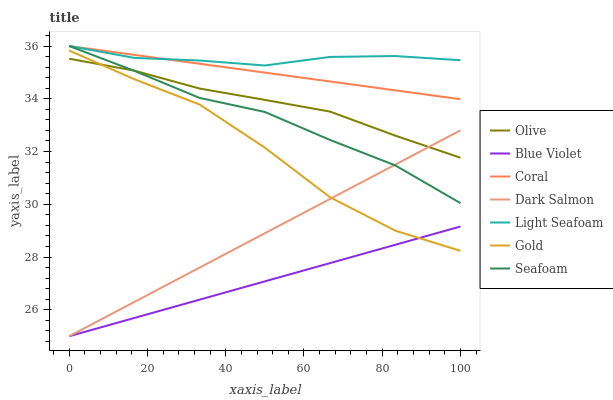Does Blue Violet have the minimum area under the curve?
Answer yes or no. Yes. Does Light Seafoam have the maximum area under the curve?
Answer yes or no. Yes. Does Coral have the minimum area under the curve?
Answer yes or no. No. Does Coral have the maximum area under the curve?
Answer yes or no. No. Is Coral the smoothest?
Answer yes or no. Yes. Is Gold the roughest?
Answer yes or no. Yes. Is Dark Salmon the smoothest?
Answer yes or no. No. Is Dark Salmon the roughest?
Answer yes or no. No. Does Coral have the lowest value?
Answer yes or no. No. Does Dark Salmon have the highest value?
Answer yes or no. No. Is Blue Violet less than Olive?
Answer yes or no. Yes. Is Light Seafoam greater than Olive?
Answer yes or no. Yes. Does Blue Violet intersect Olive?
Answer yes or no. No. 